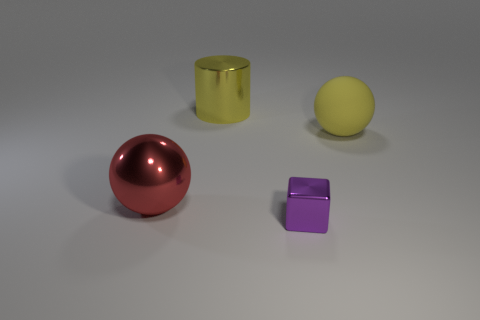Subtract all yellow balls. How many balls are left? 1 Subtract 2 spheres. How many spheres are left? 0 Add 2 small cylinders. How many objects exist? 6 Subtract all blocks. How many objects are left? 3 Add 1 purple metal blocks. How many purple metal blocks are left? 2 Add 4 small yellow matte cubes. How many small yellow matte cubes exist? 4 Subtract 0 brown cylinders. How many objects are left? 4 Subtract all brown cylinders. Subtract all gray balls. How many cylinders are left? 1 Subtract all purple cylinders. How many red spheres are left? 1 Subtract all large yellow shiny things. Subtract all yellow things. How many objects are left? 1 